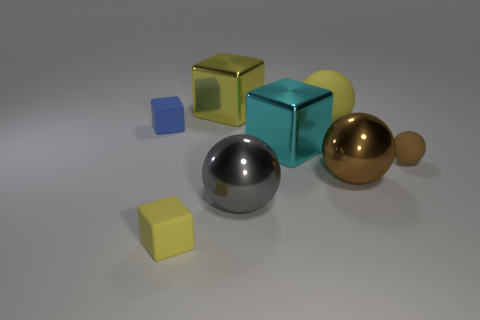Are there any green rubber cylinders of the same size as the cyan metallic thing?
Offer a very short reply. No. What is the material of the brown sphere that is the same size as the cyan thing?
Offer a terse response. Metal. What size is the brown metallic sphere that is in front of the big yellow metal cube left of the gray shiny sphere?
Offer a terse response. Large. There is a metal thing on the right side of the yellow rubber ball; does it have the same size as the big gray metallic ball?
Your answer should be compact. Yes. Is the number of large yellow cubes on the right side of the large yellow cube greater than the number of cyan metal things that are behind the small blue matte block?
Offer a terse response. No. The yellow thing that is on the left side of the big cyan metal cube and behind the cyan shiny cube has what shape?
Your response must be concise. Cube. What shape is the yellow rubber object that is behind the blue object?
Your response must be concise. Sphere. There is a metal cube that is behind the small rubber block that is on the left side of the tiny rubber cube in front of the large cyan metallic block; how big is it?
Give a very brief answer. Large. Does the large brown thing have the same shape as the big yellow matte thing?
Keep it short and to the point. Yes. What is the size of the thing that is both right of the big yellow metallic object and in front of the brown metal object?
Your response must be concise. Large. 